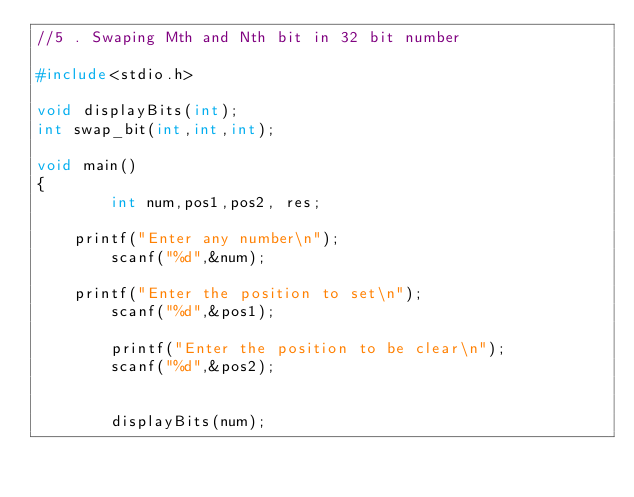Convert code to text. <code><loc_0><loc_0><loc_500><loc_500><_C_>//5 . Swaping Mth and Nth bit in 32 bit number

#include<stdio.h>

void displayBits(int);
int swap_bit(int,int,int);

void main()
{
        int num,pos1,pos2, res;
        
	printf("Enter any number\n");
        scanf("%d",&num);

	printf("Enter the position to set\n");
        scanf("%d",&pos1);

        printf("Enter the position to be clear\n");
        scanf("%d",&pos2);


        displayBits(num);</code> 